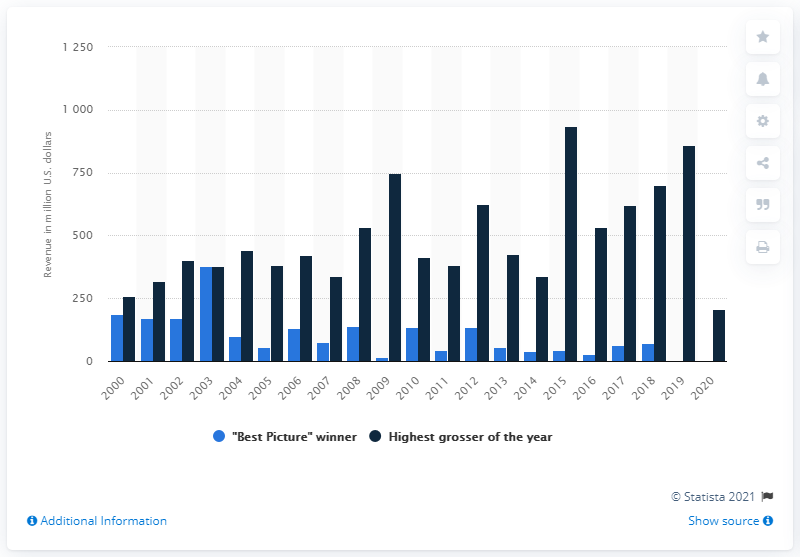Specify some key components in this picture. The box office revenue of Marvel's The Avengers in 2012 was $620.18 million. Argo's annual revenue was approximately $134.58 million. 